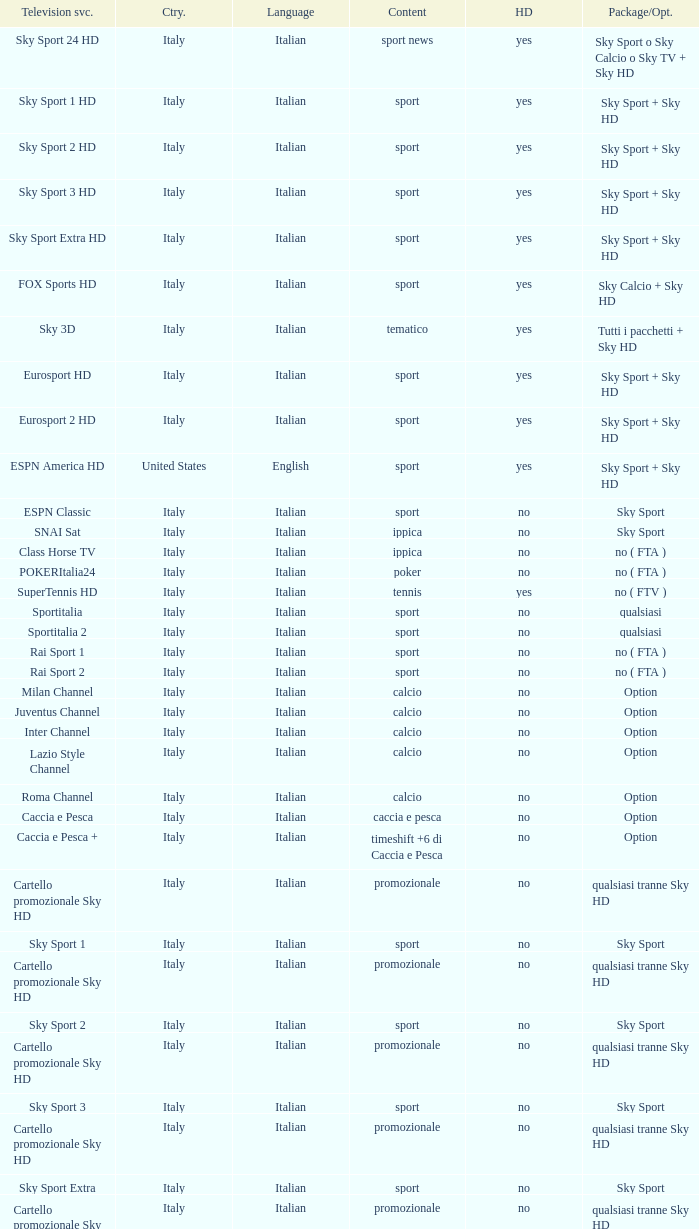What is Package/Option, when Content is Poker? No ( fta ). 